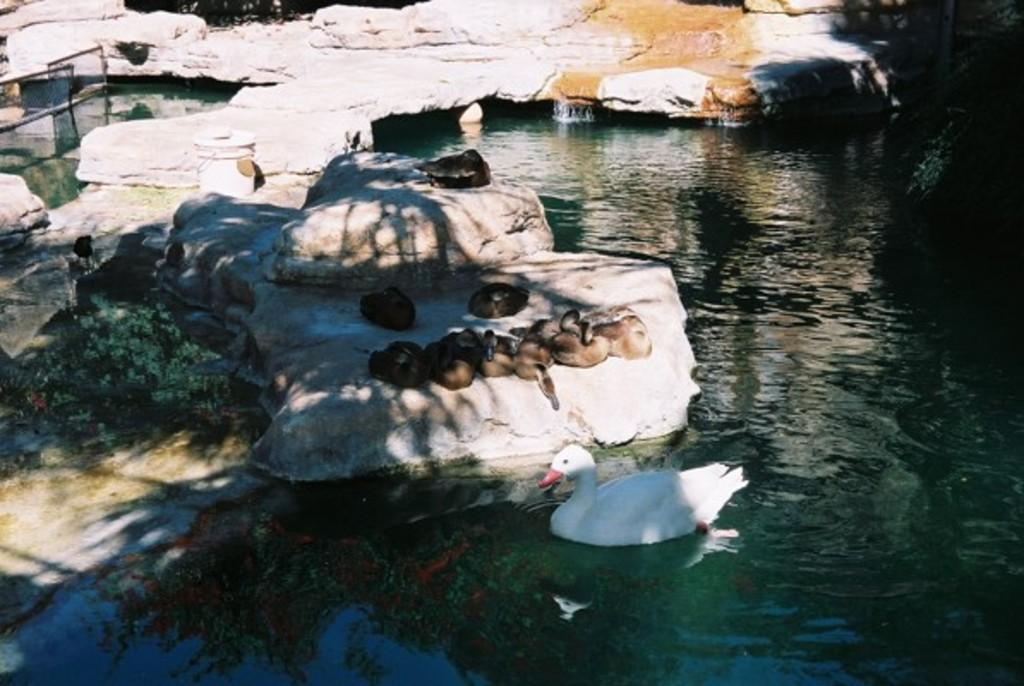What can be seen on the right side of the image? There is a water body on the right side of the image. What is near the water body? There are birds on the stones near the water body, including a duck. What type of vegetation is present in the area? There are plants in the area. How does the water body appear to function in the image? The water body appears to be a boundary. What type of cakes are being served by the judge in the image? There are no cakes or judges present in the image. How does the pancake interact with the birds in the image? There is no pancake present in the image; it features birds on stones near a water body. 